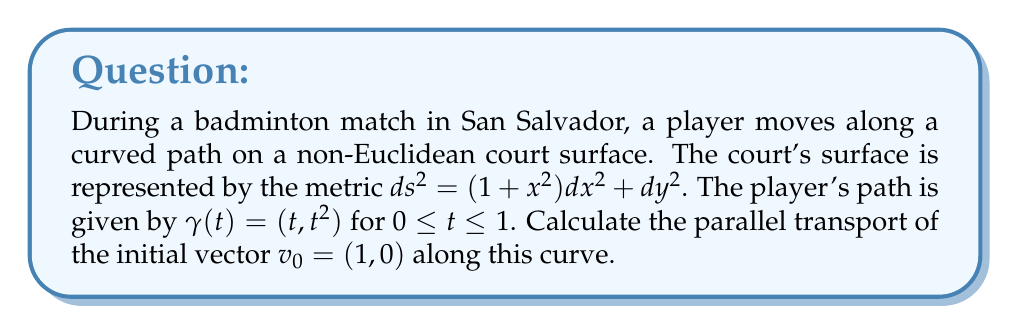Teach me how to tackle this problem. To solve this problem, we'll follow these steps:

1) First, we need to calculate the Christoffel symbols for the given metric. The non-zero Christoffel symbols are:

   $\Gamma^1_{11} = \frac{x}{1+x^2}$

2) The parallel transport equation is given by:

   $$\frac{dv^i}{dt} + \Gamma^i_{jk} \frac{dx^j}{dt} v^k = 0$$

3) For our curve $\gamma(t) = (t, t^2)$, we have $\frac{dx^1}{dt} = 1$ and $\frac{dx^2}{dt} = 2t$.

4) Let $v(t) = (v^1(t), v^2(t))$ be the parallel transported vector. The parallel transport equations become:

   $$\frac{dv^1}{dt} + \Gamma^1_{11} \frac{dx^1}{dt} v^1 = 0$$
   $$\frac{dv^2}{dt} = 0$$

5) From the second equation, we can conclude that $v^2(t) = 0$ for all $t$, as $v^2(0) = 0$.

6) The first equation becomes:

   $$\frac{dv^1}{dt} + \frac{t}{1+t^2} v^1 = 0$$

7) This is a first-order linear differential equation. Its solution is:

   $$v^1(t) = C \exp\left(-\int_0^t \frac{s}{1+s^2} ds\right) = C \sqrt{1+t^2}$$

8) Using the initial condition $v^1(0) = 1$, we find $C = 1$.

Therefore, the parallel transported vector is $v(t) = (\sqrt{1+t^2}, 0)$.
Answer: The parallel transport of the initial vector $v_0 = (1, 0)$ along the curve $\gamma(t) = (t, t^2)$ for $0 \leq t \leq 1$ is $v(t) = (\sqrt{1+t^2}, 0)$. 